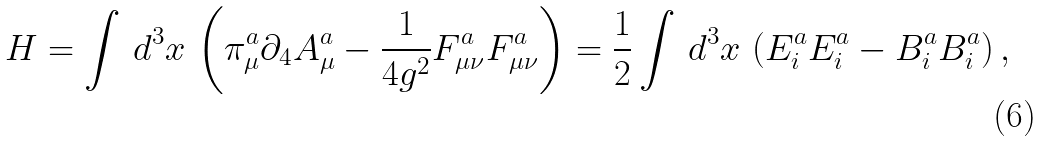Convert formula to latex. <formula><loc_0><loc_0><loc_500><loc_500>H = \int \, d ^ { 3 } x \, \left ( \pi _ { \mu } ^ { a } \partial _ { 4 } A _ { \mu } ^ { a } - \frac { 1 } { 4 g ^ { 2 } } F _ { \mu \nu } ^ { a } F _ { \mu \nu } ^ { a } \right ) = \frac { 1 } { 2 } \int \, d ^ { 3 } x \, \left ( E _ { i } ^ { a } E _ { i } ^ { a } - B _ { i } ^ { a } B _ { i } ^ { a } \right ) ,</formula> 